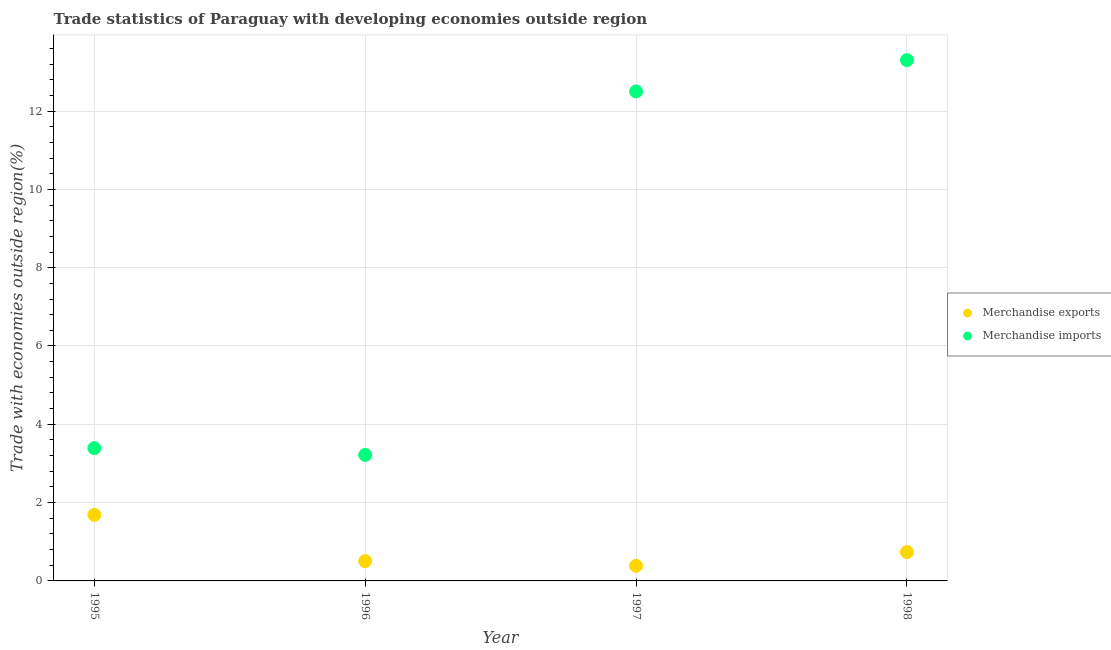How many different coloured dotlines are there?
Provide a succinct answer. 2. What is the merchandise imports in 1995?
Provide a succinct answer. 3.39. Across all years, what is the maximum merchandise imports?
Make the answer very short. 13.3. Across all years, what is the minimum merchandise imports?
Provide a succinct answer. 3.22. In which year was the merchandise exports maximum?
Your answer should be very brief. 1995. What is the total merchandise imports in the graph?
Ensure brevity in your answer.  32.41. What is the difference between the merchandise imports in 1997 and that in 1998?
Give a very brief answer. -0.8. What is the difference between the merchandise exports in 1997 and the merchandise imports in 1996?
Your answer should be very brief. -2.83. What is the average merchandise imports per year?
Give a very brief answer. 8.1. In the year 1996, what is the difference between the merchandise imports and merchandise exports?
Ensure brevity in your answer.  2.71. In how many years, is the merchandise imports greater than 8.8 %?
Provide a short and direct response. 2. What is the ratio of the merchandise exports in 1995 to that in 1998?
Make the answer very short. 2.29. Is the merchandise imports in 1997 less than that in 1998?
Your answer should be very brief. Yes. Is the difference between the merchandise imports in 1995 and 1996 greater than the difference between the merchandise exports in 1995 and 1996?
Provide a short and direct response. No. What is the difference between the highest and the second highest merchandise exports?
Make the answer very short. 0.95. What is the difference between the highest and the lowest merchandise imports?
Provide a short and direct response. 10.08. In how many years, is the merchandise exports greater than the average merchandise exports taken over all years?
Make the answer very short. 1. Does the merchandise exports monotonically increase over the years?
Ensure brevity in your answer.  No. Is the merchandise imports strictly less than the merchandise exports over the years?
Keep it short and to the point. No. How many dotlines are there?
Make the answer very short. 2. How many years are there in the graph?
Keep it short and to the point. 4. Does the graph contain any zero values?
Keep it short and to the point. No. Where does the legend appear in the graph?
Your answer should be compact. Center right. How are the legend labels stacked?
Your response must be concise. Vertical. What is the title of the graph?
Provide a succinct answer. Trade statistics of Paraguay with developing economies outside region. What is the label or title of the X-axis?
Your response must be concise. Year. What is the label or title of the Y-axis?
Keep it short and to the point. Trade with economies outside region(%). What is the Trade with economies outside region(%) in Merchandise exports in 1995?
Your answer should be very brief. 1.69. What is the Trade with economies outside region(%) in Merchandise imports in 1995?
Your response must be concise. 3.39. What is the Trade with economies outside region(%) of Merchandise exports in 1996?
Make the answer very short. 0.51. What is the Trade with economies outside region(%) of Merchandise imports in 1996?
Give a very brief answer. 3.22. What is the Trade with economies outside region(%) of Merchandise exports in 1997?
Offer a terse response. 0.39. What is the Trade with economies outside region(%) of Merchandise imports in 1997?
Offer a terse response. 12.5. What is the Trade with economies outside region(%) in Merchandise exports in 1998?
Your answer should be very brief. 0.74. What is the Trade with economies outside region(%) of Merchandise imports in 1998?
Offer a terse response. 13.3. Across all years, what is the maximum Trade with economies outside region(%) in Merchandise exports?
Offer a very short reply. 1.69. Across all years, what is the maximum Trade with economies outside region(%) of Merchandise imports?
Provide a succinct answer. 13.3. Across all years, what is the minimum Trade with economies outside region(%) of Merchandise exports?
Provide a succinct answer. 0.39. Across all years, what is the minimum Trade with economies outside region(%) of Merchandise imports?
Offer a terse response. 3.22. What is the total Trade with economies outside region(%) of Merchandise exports in the graph?
Ensure brevity in your answer.  3.32. What is the total Trade with economies outside region(%) in Merchandise imports in the graph?
Ensure brevity in your answer.  32.41. What is the difference between the Trade with economies outside region(%) in Merchandise exports in 1995 and that in 1996?
Give a very brief answer. 1.18. What is the difference between the Trade with economies outside region(%) in Merchandise imports in 1995 and that in 1996?
Keep it short and to the point. 0.17. What is the difference between the Trade with economies outside region(%) in Merchandise exports in 1995 and that in 1997?
Your response must be concise. 1.3. What is the difference between the Trade with economies outside region(%) of Merchandise imports in 1995 and that in 1997?
Ensure brevity in your answer.  -9.11. What is the difference between the Trade with economies outside region(%) of Merchandise exports in 1995 and that in 1998?
Keep it short and to the point. 0.95. What is the difference between the Trade with economies outside region(%) in Merchandise imports in 1995 and that in 1998?
Provide a short and direct response. -9.91. What is the difference between the Trade with economies outside region(%) in Merchandise exports in 1996 and that in 1997?
Your answer should be compact. 0.12. What is the difference between the Trade with economies outside region(%) of Merchandise imports in 1996 and that in 1997?
Make the answer very short. -9.28. What is the difference between the Trade with economies outside region(%) of Merchandise exports in 1996 and that in 1998?
Your answer should be very brief. -0.23. What is the difference between the Trade with economies outside region(%) in Merchandise imports in 1996 and that in 1998?
Make the answer very short. -10.08. What is the difference between the Trade with economies outside region(%) of Merchandise exports in 1997 and that in 1998?
Offer a terse response. -0.35. What is the difference between the Trade with economies outside region(%) of Merchandise imports in 1997 and that in 1998?
Your answer should be very brief. -0.8. What is the difference between the Trade with economies outside region(%) of Merchandise exports in 1995 and the Trade with economies outside region(%) of Merchandise imports in 1996?
Your response must be concise. -1.53. What is the difference between the Trade with economies outside region(%) of Merchandise exports in 1995 and the Trade with economies outside region(%) of Merchandise imports in 1997?
Your answer should be very brief. -10.81. What is the difference between the Trade with economies outside region(%) in Merchandise exports in 1995 and the Trade with economies outside region(%) in Merchandise imports in 1998?
Give a very brief answer. -11.61. What is the difference between the Trade with economies outside region(%) of Merchandise exports in 1996 and the Trade with economies outside region(%) of Merchandise imports in 1997?
Ensure brevity in your answer.  -12. What is the difference between the Trade with economies outside region(%) in Merchandise exports in 1996 and the Trade with economies outside region(%) in Merchandise imports in 1998?
Offer a very short reply. -12.79. What is the difference between the Trade with economies outside region(%) in Merchandise exports in 1997 and the Trade with economies outside region(%) in Merchandise imports in 1998?
Provide a short and direct response. -12.91. What is the average Trade with economies outside region(%) in Merchandise exports per year?
Provide a succinct answer. 0.83. What is the average Trade with economies outside region(%) of Merchandise imports per year?
Provide a short and direct response. 8.1. In the year 1995, what is the difference between the Trade with economies outside region(%) in Merchandise exports and Trade with economies outside region(%) in Merchandise imports?
Give a very brief answer. -1.7. In the year 1996, what is the difference between the Trade with economies outside region(%) of Merchandise exports and Trade with economies outside region(%) of Merchandise imports?
Provide a succinct answer. -2.71. In the year 1997, what is the difference between the Trade with economies outside region(%) in Merchandise exports and Trade with economies outside region(%) in Merchandise imports?
Provide a succinct answer. -12.12. In the year 1998, what is the difference between the Trade with economies outside region(%) in Merchandise exports and Trade with economies outside region(%) in Merchandise imports?
Your response must be concise. -12.56. What is the ratio of the Trade with economies outside region(%) in Merchandise exports in 1995 to that in 1996?
Your response must be concise. 3.34. What is the ratio of the Trade with economies outside region(%) of Merchandise imports in 1995 to that in 1996?
Keep it short and to the point. 1.05. What is the ratio of the Trade with economies outside region(%) in Merchandise exports in 1995 to that in 1997?
Offer a terse response. 4.38. What is the ratio of the Trade with economies outside region(%) of Merchandise imports in 1995 to that in 1997?
Provide a short and direct response. 0.27. What is the ratio of the Trade with economies outside region(%) of Merchandise exports in 1995 to that in 1998?
Your answer should be very brief. 2.29. What is the ratio of the Trade with economies outside region(%) of Merchandise imports in 1995 to that in 1998?
Give a very brief answer. 0.26. What is the ratio of the Trade with economies outside region(%) of Merchandise exports in 1996 to that in 1997?
Ensure brevity in your answer.  1.31. What is the ratio of the Trade with economies outside region(%) of Merchandise imports in 1996 to that in 1997?
Provide a short and direct response. 0.26. What is the ratio of the Trade with economies outside region(%) in Merchandise exports in 1996 to that in 1998?
Provide a succinct answer. 0.69. What is the ratio of the Trade with economies outside region(%) in Merchandise imports in 1996 to that in 1998?
Keep it short and to the point. 0.24. What is the ratio of the Trade with economies outside region(%) of Merchandise exports in 1997 to that in 1998?
Provide a short and direct response. 0.52. What is the ratio of the Trade with economies outside region(%) in Merchandise imports in 1997 to that in 1998?
Provide a short and direct response. 0.94. What is the difference between the highest and the second highest Trade with economies outside region(%) of Merchandise exports?
Keep it short and to the point. 0.95. What is the difference between the highest and the second highest Trade with economies outside region(%) in Merchandise imports?
Offer a very short reply. 0.8. What is the difference between the highest and the lowest Trade with economies outside region(%) of Merchandise exports?
Keep it short and to the point. 1.3. What is the difference between the highest and the lowest Trade with economies outside region(%) in Merchandise imports?
Make the answer very short. 10.08. 